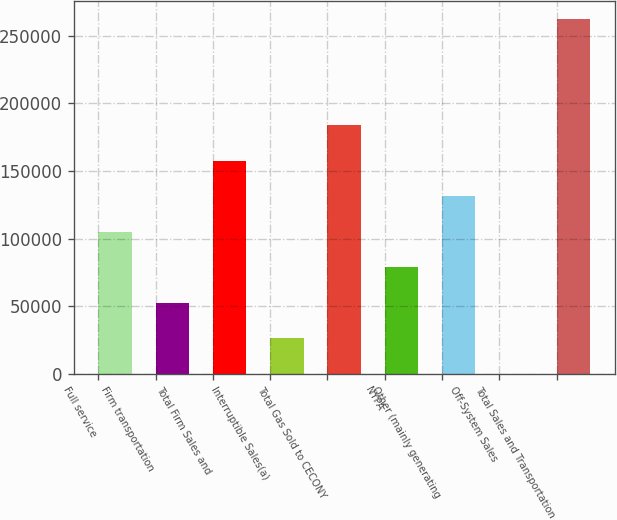Convert chart. <chart><loc_0><loc_0><loc_500><loc_500><bar_chart><fcel>Full service<fcel>Firm transportation<fcel>Total Firm Sales and<fcel>Interruptible Sales(a)<fcel>Total Gas Sold to CECONY<fcel>NYPA<fcel>Other (mainly generating<fcel>Off-System Sales<fcel>Total Sales and Transportation<nl><fcel>105029<fcel>52591.6<fcel>157467<fcel>26372.8<fcel>183686<fcel>78810.4<fcel>131248<fcel>154<fcel>262342<nl></chart> 